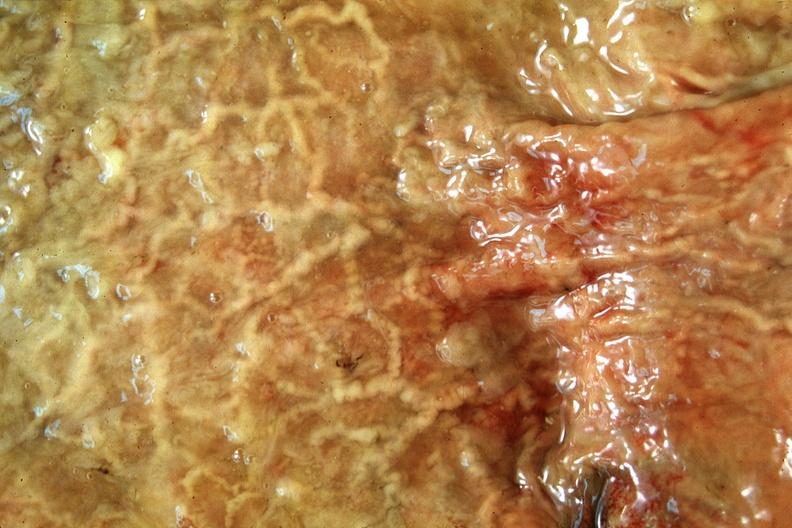does another fiber other frame show normal stomach?
Answer the question using a single word or phrase. No 